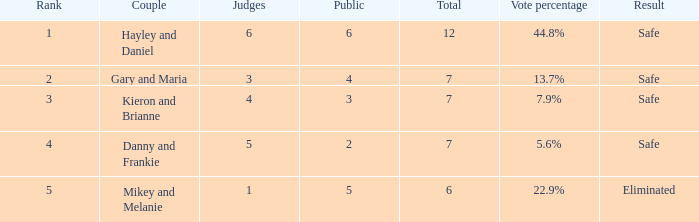What was the total number when the vote percentage was 44.8%? 1.0. 